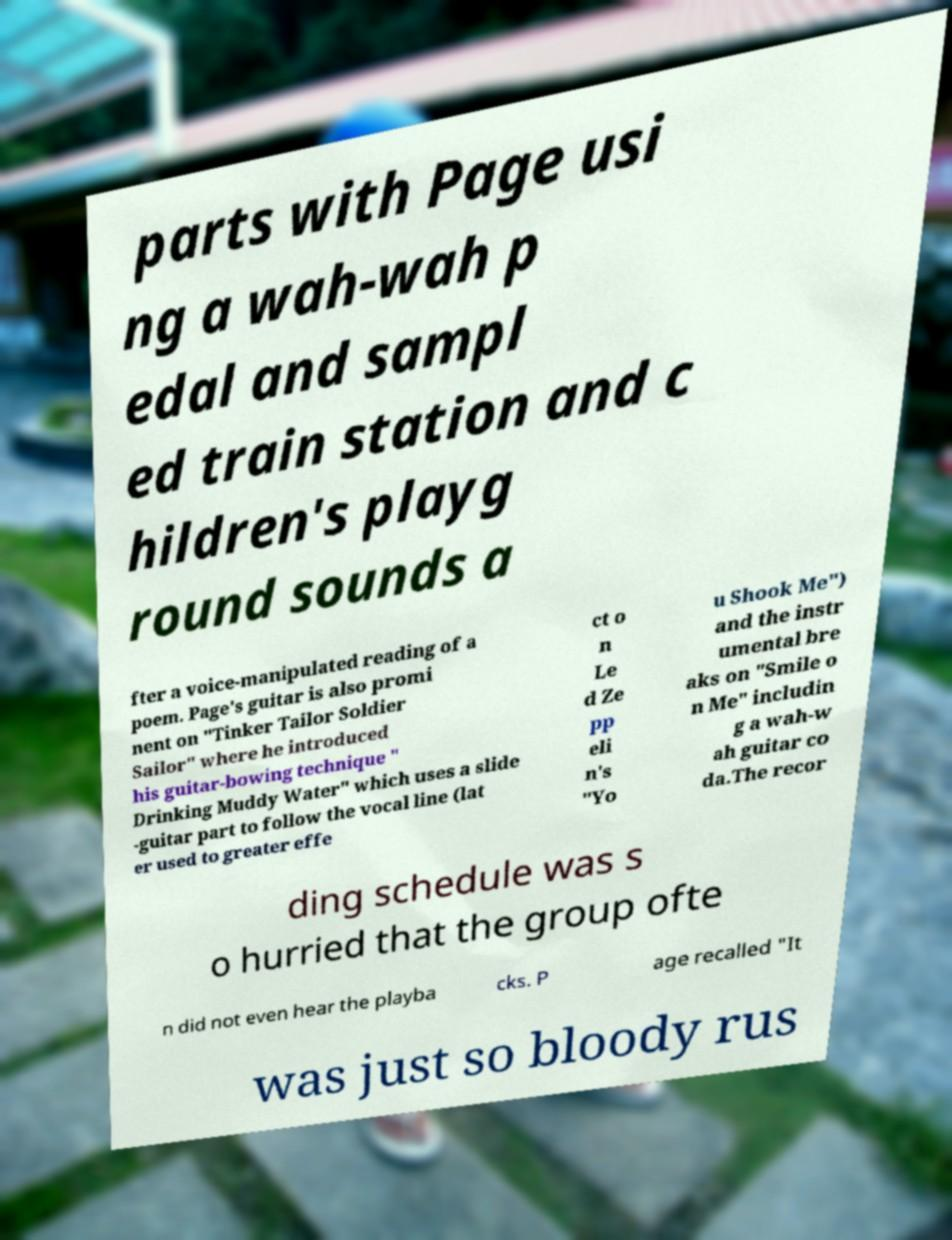I need the written content from this picture converted into text. Can you do that? parts with Page usi ng a wah-wah p edal and sampl ed train station and c hildren's playg round sounds a fter a voice-manipulated reading of a poem. Page's guitar is also promi nent on "Tinker Tailor Soldier Sailor" where he introduced his guitar-bowing technique " Drinking Muddy Water" which uses a slide -guitar part to follow the vocal line (lat er used to greater effe ct o n Le d Ze pp eli n's "Yo u Shook Me") and the instr umental bre aks on "Smile o n Me" includin g a wah-w ah guitar co da.The recor ding schedule was s o hurried that the group ofte n did not even hear the playba cks. P age recalled "It was just so bloody rus 